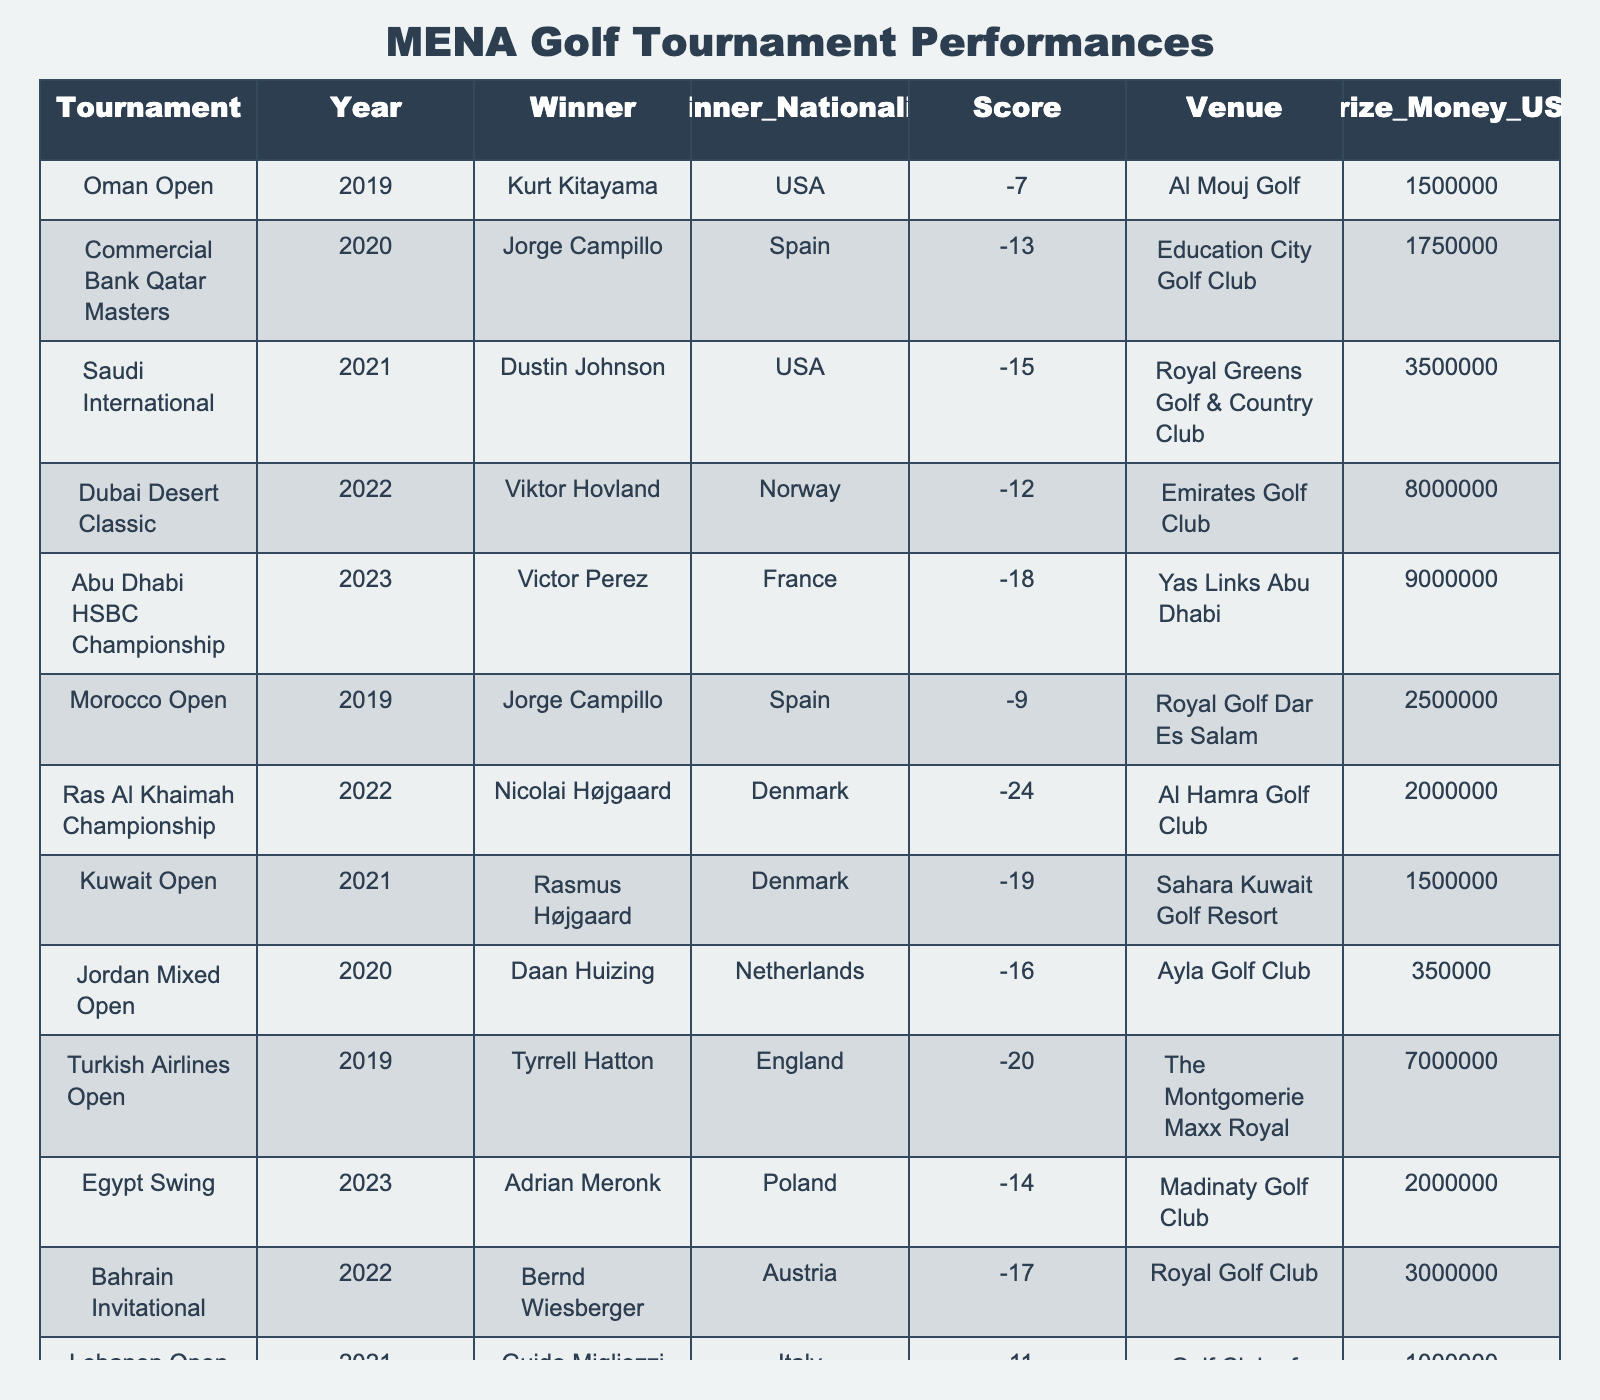What was the winning score of the Abu Dhabi HSBC Championship in 2023? We can look at the row in the table corresponding to the Abu Dhabi HSBC Championship in 2023, where the score is listed as -18.
Answer: -18 Which tournament had the highest prize money? By checking the prize money column in the table, we see that the Dubai Desert Classic in 2022 had the highest prize money of $8,000,000.
Answer: Dubai Desert Classic Who won the Saudi International in 2021? Directly referring to the row for the Saudi International in 2021, the winner is Dustin Johnson.
Answer: Dustin Johnson How many tournaments did Jorge Campillo win from 2019 to 2020? Looking at the table, Jorge Campillo won the Oman Open in 2019 and the Commercial Bank Qatar Masters in 2020, totaling two victories.
Answer: 2 What was the prize money of the Kuwait Open in 2021 compared to the Jordan Mixed Open in 2020? The Kuwait Open in 2021 had a prize money of $1,500,000 and the Jordan Mixed Open in 2020 had $350,000. Comparing these, $1,500,000 is significantly more than $350,000.
Answer: Kuwait Open had more Which country had the most winners in this table? After analyzing the winner nationality column, the USA (with 3 wins) and Spain (with 3 wins) are tied for the highest number of wins, so we need to check for other countries like Denmark and others for their counts.
Answer: USA and Spain, both with 3 wins What was the average score of the tournament winners in 2022? The winners in 2022 were Nicolai Højgaard (-24) in the Ras Al Khaimah Championship, Bernd Wiesberger (-17) in the Bahrain Invitational, and Viktor Hovland (-12) in the Dubai Desert Classic. Adding these scores gives (-24 + -17 + -12) = -53, and then dividing by 3 gives an average score of -17.67.
Answer: -17.67 Which player won in the most recent tournament in the MENA region? The most recent tournament in the table is the UAE Challenge in 2023, where Adri Arnaus was the winner.
Answer: Adri Arnaus What is the total prize money distributed among all tournaments listed in the table? We need to sum all the prize money amounts from each tournament: $1,500,000 (Oman Open) + $1,750,000 (Qatar Masters) + $3,500,000 (Saudi International) + $8,000,000 (Dubai Desert Classic) + $9,000,000 (Abu Dhabi HSBC) + $2,500,000 (Morocco Open) + $2,000,000 (Ras Al Khaimah Championship) + $1,500,000 (Kuwait Open) + $350,000 (Jordan Mixed Open) + $7,000,000 (Turkish Airlines Open) + $2,000,000 (Egypt Swing) + $3,000,000 (Bahrain Invitational) + $1,000,000 (Lebanon Open) + $1,250,000 (Tunisia Open) + $500,000 (UAE Challenge), resulting in a total of $43,850,000.
Answer: $43,850,000 Which venue hosted the lowest scoring tournament winner, and what was the score? By reviewing the scores, the lowest score is -25, achieved at the Carthage Golf Club during the Tunisia Open in 2020.
Answer: Carthage Golf Club, -25 